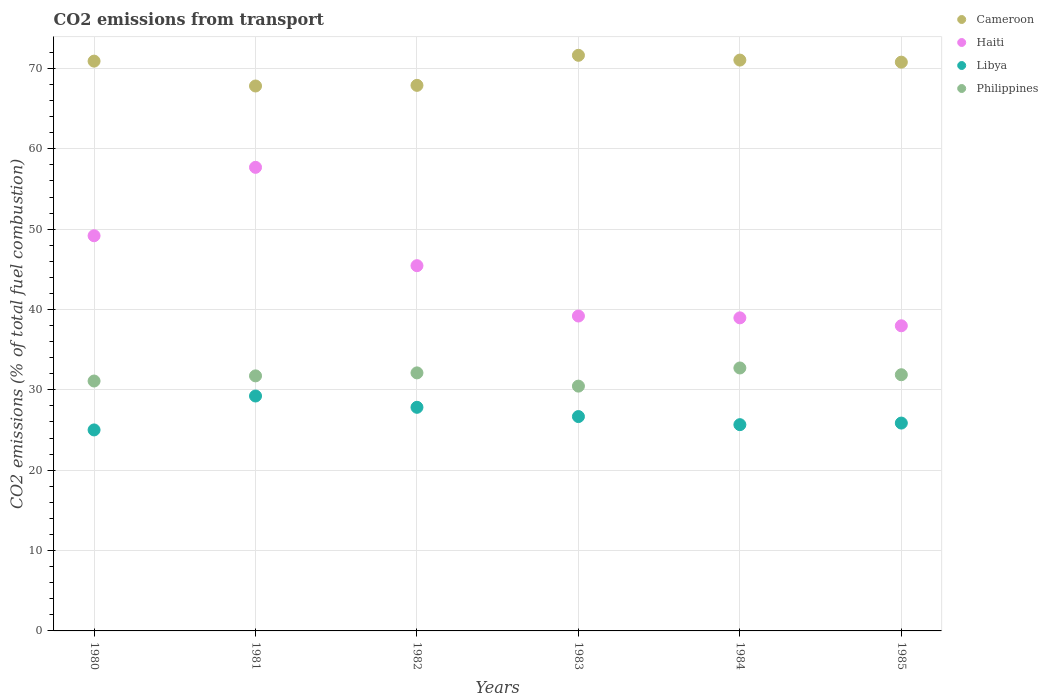What is the total CO2 emitted in Haiti in 1980?
Make the answer very short. 49.18. Across all years, what is the maximum total CO2 emitted in Philippines?
Ensure brevity in your answer.  32.72. Across all years, what is the minimum total CO2 emitted in Philippines?
Make the answer very short. 30.46. In which year was the total CO2 emitted in Cameroon minimum?
Your answer should be very brief. 1981. What is the total total CO2 emitted in Philippines in the graph?
Your answer should be compact. 190.02. What is the difference between the total CO2 emitted in Cameroon in 1981 and that in 1984?
Offer a terse response. -3.22. What is the difference between the total CO2 emitted in Haiti in 1985 and the total CO2 emitted in Cameroon in 1984?
Make the answer very short. -33.07. What is the average total CO2 emitted in Cameroon per year?
Offer a very short reply. 70.01. In the year 1983, what is the difference between the total CO2 emitted in Libya and total CO2 emitted in Haiti?
Offer a very short reply. -12.51. In how many years, is the total CO2 emitted in Libya greater than 58?
Offer a terse response. 0. What is the ratio of the total CO2 emitted in Philippines in 1980 to that in 1983?
Provide a succinct answer. 1.02. Is the total CO2 emitted in Cameroon in 1982 less than that in 1984?
Ensure brevity in your answer.  Yes. What is the difference between the highest and the second highest total CO2 emitted in Libya?
Your answer should be compact. 1.41. What is the difference between the highest and the lowest total CO2 emitted in Haiti?
Make the answer very short. 19.72. Is it the case that in every year, the sum of the total CO2 emitted in Haiti and total CO2 emitted in Philippines  is greater than the sum of total CO2 emitted in Cameroon and total CO2 emitted in Libya?
Provide a short and direct response. No. How many dotlines are there?
Your answer should be compact. 4. How many years are there in the graph?
Give a very brief answer. 6. What is the difference between two consecutive major ticks on the Y-axis?
Give a very brief answer. 10. Are the values on the major ticks of Y-axis written in scientific E-notation?
Your response must be concise. No. Does the graph contain grids?
Ensure brevity in your answer.  Yes. Where does the legend appear in the graph?
Give a very brief answer. Top right. What is the title of the graph?
Ensure brevity in your answer.  CO2 emissions from transport. What is the label or title of the X-axis?
Your response must be concise. Years. What is the label or title of the Y-axis?
Offer a terse response. CO2 emissions (% of total fuel combustion). What is the CO2 emissions (% of total fuel combustion) of Cameroon in 1980?
Provide a succinct answer. 70.91. What is the CO2 emissions (% of total fuel combustion) of Haiti in 1980?
Keep it short and to the point. 49.18. What is the CO2 emissions (% of total fuel combustion) in Libya in 1980?
Your answer should be compact. 25.01. What is the CO2 emissions (% of total fuel combustion) in Philippines in 1980?
Make the answer very short. 31.1. What is the CO2 emissions (% of total fuel combustion) of Cameroon in 1981?
Offer a terse response. 67.82. What is the CO2 emissions (% of total fuel combustion) of Haiti in 1981?
Offer a terse response. 57.69. What is the CO2 emissions (% of total fuel combustion) of Libya in 1981?
Your answer should be very brief. 29.23. What is the CO2 emissions (% of total fuel combustion) of Philippines in 1981?
Give a very brief answer. 31.74. What is the CO2 emissions (% of total fuel combustion) of Cameroon in 1982?
Provide a succinct answer. 67.89. What is the CO2 emissions (% of total fuel combustion) in Haiti in 1982?
Ensure brevity in your answer.  45.45. What is the CO2 emissions (% of total fuel combustion) in Libya in 1982?
Offer a very short reply. 27.83. What is the CO2 emissions (% of total fuel combustion) of Philippines in 1982?
Ensure brevity in your answer.  32.11. What is the CO2 emissions (% of total fuel combustion) of Cameroon in 1983?
Make the answer very short. 71.63. What is the CO2 emissions (% of total fuel combustion) of Haiti in 1983?
Provide a short and direct response. 39.19. What is the CO2 emissions (% of total fuel combustion) in Libya in 1983?
Provide a succinct answer. 26.68. What is the CO2 emissions (% of total fuel combustion) in Philippines in 1983?
Make the answer very short. 30.46. What is the CO2 emissions (% of total fuel combustion) in Cameroon in 1984?
Give a very brief answer. 71.04. What is the CO2 emissions (% of total fuel combustion) of Haiti in 1984?
Provide a succinct answer. 38.96. What is the CO2 emissions (% of total fuel combustion) of Libya in 1984?
Keep it short and to the point. 25.67. What is the CO2 emissions (% of total fuel combustion) in Philippines in 1984?
Give a very brief answer. 32.72. What is the CO2 emissions (% of total fuel combustion) in Cameroon in 1985?
Your answer should be compact. 70.78. What is the CO2 emissions (% of total fuel combustion) in Haiti in 1985?
Give a very brief answer. 37.97. What is the CO2 emissions (% of total fuel combustion) of Libya in 1985?
Ensure brevity in your answer.  25.87. What is the CO2 emissions (% of total fuel combustion) in Philippines in 1985?
Offer a very short reply. 31.88. Across all years, what is the maximum CO2 emissions (% of total fuel combustion) in Cameroon?
Provide a succinct answer. 71.63. Across all years, what is the maximum CO2 emissions (% of total fuel combustion) in Haiti?
Provide a short and direct response. 57.69. Across all years, what is the maximum CO2 emissions (% of total fuel combustion) in Libya?
Provide a succinct answer. 29.23. Across all years, what is the maximum CO2 emissions (% of total fuel combustion) in Philippines?
Provide a succinct answer. 32.72. Across all years, what is the minimum CO2 emissions (% of total fuel combustion) of Cameroon?
Offer a terse response. 67.82. Across all years, what is the minimum CO2 emissions (% of total fuel combustion) in Haiti?
Your answer should be very brief. 37.97. Across all years, what is the minimum CO2 emissions (% of total fuel combustion) of Libya?
Provide a short and direct response. 25.01. Across all years, what is the minimum CO2 emissions (% of total fuel combustion) in Philippines?
Your answer should be very brief. 30.46. What is the total CO2 emissions (% of total fuel combustion) in Cameroon in the graph?
Your answer should be compact. 420.08. What is the total CO2 emissions (% of total fuel combustion) of Haiti in the graph?
Offer a terse response. 268.45. What is the total CO2 emissions (% of total fuel combustion) in Libya in the graph?
Offer a terse response. 160.29. What is the total CO2 emissions (% of total fuel combustion) in Philippines in the graph?
Keep it short and to the point. 190.02. What is the difference between the CO2 emissions (% of total fuel combustion) of Cameroon in 1980 and that in 1981?
Your answer should be very brief. 3.09. What is the difference between the CO2 emissions (% of total fuel combustion) in Haiti in 1980 and that in 1981?
Your response must be concise. -8.51. What is the difference between the CO2 emissions (% of total fuel combustion) of Libya in 1980 and that in 1981?
Give a very brief answer. -4.22. What is the difference between the CO2 emissions (% of total fuel combustion) in Philippines in 1980 and that in 1981?
Offer a terse response. -0.64. What is the difference between the CO2 emissions (% of total fuel combustion) of Cameroon in 1980 and that in 1982?
Your response must be concise. 3.01. What is the difference between the CO2 emissions (% of total fuel combustion) of Haiti in 1980 and that in 1982?
Your answer should be compact. 3.73. What is the difference between the CO2 emissions (% of total fuel combustion) of Libya in 1980 and that in 1982?
Offer a terse response. -2.82. What is the difference between the CO2 emissions (% of total fuel combustion) of Philippines in 1980 and that in 1982?
Ensure brevity in your answer.  -1.01. What is the difference between the CO2 emissions (% of total fuel combustion) in Cameroon in 1980 and that in 1983?
Give a very brief answer. -0.73. What is the difference between the CO2 emissions (% of total fuel combustion) in Haiti in 1980 and that in 1983?
Make the answer very short. 9.99. What is the difference between the CO2 emissions (% of total fuel combustion) of Libya in 1980 and that in 1983?
Keep it short and to the point. -1.66. What is the difference between the CO2 emissions (% of total fuel combustion) of Philippines in 1980 and that in 1983?
Make the answer very short. 0.64. What is the difference between the CO2 emissions (% of total fuel combustion) of Cameroon in 1980 and that in 1984?
Your response must be concise. -0.13. What is the difference between the CO2 emissions (% of total fuel combustion) in Haiti in 1980 and that in 1984?
Ensure brevity in your answer.  10.22. What is the difference between the CO2 emissions (% of total fuel combustion) in Libya in 1980 and that in 1984?
Your response must be concise. -0.66. What is the difference between the CO2 emissions (% of total fuel combustion) of Philippines in 1980 and that in 1984?
Keep it short and to the point. -1.62. What is the difference between the CO2 emissions (% of total fuel combustion) of Cameroon in 1980 and that in 1985?
Ensure brevity in your answer.  0.13. What is the difference between the CO2 emissions (% of total fuel combustion) of Haiti in 1980 and that in 1985?
Make the answer very short. 11.21. What is the difference between the CO2 emissions (% of total fuel combustion) of Libya in 1980 and that in 1985?
Offer a very short reply. -0.85. What is the difference between the CO2 emissions (% of total fuel combustion) in Philippines in 1980 and that in 1985?
Ensure brevity in your answer.  -0.78. What is the difference between the CO2 emissions (% of total fuel combustion) in Cameroon in 1981 and that in 1982?
Your answer should be compact. -0.08. What is the difference between the CO2 emissions (% of total fuel combustion) in Haiti in 1981 and that in 1982?
Your answer should be very brief. 12.24. What is the difference between the CO2 emissions (% of total fuel combustion) of Libya in 1981 and that in 1982?
Provide a short and direct response. 1.41. What is the difference between the CO2 emissions (% of total fuel combustion) of Philippines in 1981 and that in 1982?
Provide a short and direct response. -0.37. What is the difference between the CO2 emissions (% of total fuel combustion) in Cameroon in 1981 and that in 1983?
Offer a very short reply. -3.82. What is the difference between the CO2 emissions (% of total fuel combustion) of Haiti in 1981 and that in 1983?
Offer a very short reply. 18.5. What is the difference between the CO2 emissions (% of total fuel combustion) in Libya in 1981 and that in 1983?
Offer a terse response. 2.56. What is the difference between the CO2 emissions (% of total fuel combustion) in Philippines in 1981 and that in 1983?
Your response must be concise. 1.28. What is the difference between the CO2 emissions (% of total fuel combustion) in Cameroon in 1981 and that in 1984?
Your response must be concise. -3.22. What is the difference between the CO2 emissions (% of total fuel combustion) in Haiti in 1981 and that in 1984?
Provide a succinct answer. 18.73. What is the difference between the CO2 emissions (% of total fuel combustion) in Libya in 1981 and that in 1984?
Keep it short and to the point. 3.57. What is the difference between the CO2 emissions (% of total fuel combustion) in Philippines in 1981 and that in 1984?
Provide a succinct answer. -0.98. What is the difference between the CO2 emissions (% of total fuel combustion) in Cameroon in 1981 and that in 1985?
Ensure brevity in your answer.  -2.97. What is the difference between the CO2 emissions (% of total fuel combustion) in Haiti in 1981 and that in 1985?
Offer a very short reply. 19.72. What is the difference between the CO2 emissions (% of total fuel combustion) in Libya in 1981 and that in 1985?
Give a very brief answer. 3.37. What is the difference between the CO2 emissions (% of total fuel combustion) of Philippines in 1981 and that in 1985?
Offer a very short reply. -0.14. What is the difference between the CO2 emissions (% of total fuel combustion) in Cameroon in 1982 and that in 1983?
Offer a terse response. -3.74. What is the difference between the CO2 emissions (% of total fuel combustion) in Haiti in 1982 and that in 1983?
Keep it short and to the point. 6.27. What is the difference between the CO2 emissions (% of total fuel combustion) in Libya in 1982 and that in 1983?
Your response must be concise. 1.15. What is the difference between the CO2 emissions (% of total fuel combustion) in Philippines in 1982 and that in 1983?
Ensure brevity in your answer.  1.65. What is the difference between the CO2 emissions (% of total fuel combustion) in Cameroon in 1982 and that in 1984?
Your answer should be very brief. -3.15. What is the difference between the CO2 emissions (% of total fuel combustion) in Haiti in 1982 and that in 1984?
Your answer should be compact. 6.49. What is the difference between the CO2 emissions (% of total fuel combustion) of Libya in 1982 and that in 1984?
Ensure brevity in your answer.  2.16. What is the difference between the CO2 emissions (% of total fuel combustion) in Philippines in 1982 and that in 1984?
Offer a terse response. -0.61. What is the difference between the CO2 emissions (% of total fuel combustion) of Cameroon in 1982 and that in 1985?
Ensure brevity in your answer.  -2.89. What is the difference between the CO2 emissions (% of total fuel combustion) of Haiti in 1982 and that in 1985?
Ensure brevity in your answer.  7.48. What is the difference between the CO2 emissions (% of total fuel combustion) of Libya in 1982 and that in 1985?
Ensure brevity in your answer.  1.96. What is the difference between the CO2 emissions (% of total fuel combustion) in Philippines in 1982 and that in 1985?
Ensure brevity in your answer.  0.23. What is the difference between the CO2 emissions (% of total fuel combustion) of Cameroon in 1983 and that in 1984?
Your answer should be very brief. 0.59. What is the difference between the CO2 emissions (% of total fuel combustion) of Haiti in 1983 and that in 1984?
Keep it short and to the point. 0.23. What is the difference between the CO2 emissions (% of total fuel combustion) of Libya in 1983 and that in 1984?
Your response must be concise. 1.01. What is the difference between the CO2 emissions (% of total fuel combustion) of Philippines in 1983 and that in 1984?
Make the answer very short. -2.26. What is the difference between the CO2 emissions (% of total fuel combustion) in Cameroon in 1983 and that in 1985?
Give a very brief answer. 0.85. What is the difference between the CO2 emissions (% of total fuel combustion) of Haiti in 1983 and that in 1985?
Make the answer very short. 1.21. What is the difference between the CO2 emissions (% of total fuel combustion) in Libya in 1983 and that in 1985?
Ensure brevity in your answer.  0.81. What is the difference between the CO2 emissions (% of total fuel combustion) in Philippines in 1983 and that in 1985?
Ensure brevity in your answer.  -1.42. What is the difference between the CO2 emissions (% of total fuel combustion) of Cameroon in 1984 and that in 1985?
Your response must be concise. 0.26. What is the difference between the CO2 emissions (% of total fuel combustion) in Haiti in 1984 and that in 1985?
Give a very brief answer. 0.99. What is the difference between the CO2 emissions (% of total fuel combustion) in Libya in 1984 and that in 1985?
Provide a succinct answer. -0.2. What is the difference between the CO2 emissions (% of total fuel combustion) of Philippines in 1984 and that in 1985?
Ensure brevity in your answer.  0.84. What is the difference between the CO2 emissions (% of total fuel combustion) in Cameroon in 1980 and the CO2 emissions (% of total fuel combustion) in Haiti in 1981?
Your answer should be compact. 13.22. What is the difference between the CO2 emissions (% of total fuel combustion) of Cameroon in 1980 and the CO2 emissions (% of total fuel combustion) of Libya in 1981?
Your response must be concise. 41.67. What is the difference between the CO2 emissions (% of total fuel combustion) in Cameroon in 1980 and the CO2 emissions (% of total fuel combustion) in Philippines in 1981?
Offer a very short reply. 39.17. What is the difference between the CO2 emissions (% of total fuel combustion) in Haiti in 1980 and the CO2 emissions (% of total fuel combustion) in Libya in 1981?
Your answer should be very brief. 19.95. What is the difference between the CO2 emissions (% of total fuel combustion) of Haiti in 1980 and the CO2 emissions (% of total fuel combustion) of Philippines in 1981?
Provide a short and direct response. 17.44. What is the difference between the CO2 emissions (% of total fuel combustion) of Libya in 1980 and the CO2 emissions (% of total fuel combustion) of Philippines in 1981?
Make the answer very short. -6.73. What is the difference between the CO2 emissions (% of total fuel combustion) of Cameroon in 1980 and the CO2 emissions (% of total fuel combustion) of Haiti in 1982?
Ensure brevity in your answer.  25.45. What is the difference between the CO2 emissions (% of total fuel combustion) in Cameroon in 1980 and the CO2 emissions (% of total fuel combustion) in Libya in 1982?
Your response must be concise. 43.08. What is the difference between the CO2 emissions (% of total fuel combustion) in Cameroon in 1980 and the CO2 emissions (% of total fuel combustion) in Philippines in 1982?
Your answer should be compact. 38.8. What is the difference between the CO2 emissions (% of total fuel combustion) of Haiti in 1980 and the CO2 emissions (% of total fuel combustion) of Libya in 1982?
Make the answer very short. 21.35. What is the difference between the CO2 emissions (% of total fuel combustion) in Haiti in 1980 and the CO2 emissions (% of total fuel combustion) in Philippines in 1982?
Provide a short and direct response. 17.07. What is the difference between the CO2 emissions (% of total fuel combustion) in Libya in 1980 and the CO2 emissions (% of total fuel combustion) in Philippines in 1982?
Offer a terse response. -7.1. What is the difference between the CO2 emissions (% of total fuel combustion) of Cameroon in 1980 and the CO2 emissions (% of total fuel combustion) of Haiti in 1983?
Keep it short and to the point. 31.72. What is the difference between the CO2 emissions (% of total fuel combustion) of Cameroon in 1980 and the CO2 emissions (% of total fuel combustion) of Libya in 1983?
Ensure brevity in your answer.  44.23. What is the difference between the CO2 emissions (% of total fuel combustion) in Cameroon in 1980 and the CO2 emissions (% of total fuel combustion) in Philippines in 1983?
Ensure brevity in your answer.  40.44. What is the difference between the CO2 emissions (% of total fuel combustion) of Haiti in 1980 and the CO2 emissions (% of total fuel combustion) of Libya in 1983?
Give a very brief answer. 22.5. What is the difference between the CO2 emissions (% of total fuel combustion) in Haiti in 1980 and the CO2 emissions (% of total fuel combustion) in Philippines in 1983?
Your answer should be very brief. 18.72. What is the difference between the CO2 emissions (% of total fuel combustion) in Libya in 1980 and the CO2 emissions (% of total fuel combustion) in Philippines in 1983?
Your answer should be very brief. -5.45. What is the difference between the CO2 emissions (% of total fuel combustion) of Cameroon in 1980 and the CO2 emissions (% of total fuel combustion) of Haiti in 1984?
Make the answer very short. 31.95. What is the difference between the CO2 emissions (% of total fuel combustion) in Cameroon in 1980 and the CO2 emissions (% of total fuel combustion) in Libya in 1984?
Your answer should be compact. 45.24. What is the difference between the CO2 emissions (% of total fuel combustion) in Cameroon in 1980 and the CO2 emissions (% of total fuel combustion) in Philippines in 1984?
Provide a short and direct response. 38.19. What is the difference between the CO2 emissions (% of total fuel combustion) of Haiti in 1980 and the CO2 emissions (% of total fuel combustion) of Libya in 1984?
Offer a terse response. 23.51. What is the difference between the CO2 emissions (% of total fuel combustion) in Haiti in 1980 and the CO2 emissions (% of total fuel combustion) in Philippines in 1984?
Your answer should be very brief. 16.46. What is the difference between the CO2 emissions (% of total fuel combustion) of Libya in 1980 and the CO2 emissions (% of total fuel combustion) of Philippines in 1984?
Your response must be concise. -7.71. What is the difference between the CO2 emissions (% of total fuel combustion) of Cameroon in 1980 and the CO2 emissions (% of total fuel combustion) of Haiti in 1985?
Keep it short and to the point. 32.93. What is the difference between the CO2 emissions (% of total fuel combustion) of Cameroon in 1980 and the CO2 emissions (% of total fuel combustion) of Libya in 1985?
Ensure brevity in your answer.  45.04. What is the difference between the CO2 emissions (% of total fuel combustion) of Cameroon in 1980 and the CO2 emissions (% of total fuel combustion) of Philippines in 1985?
Provide a succinct answer. 39.03. What is the difference between the CO2 emissions (% of total fuel combustion) in Haiti in 1980 and the CO2 emissions (% of total fuel combustion) in Libya in 1985?
Your answer should be very brief. 23.31. What is the difference between the CO2 emissions (% of total fuel combustion) in Haiti in 1980 and the CO2 emissions (% of total fuel combustion) in Philippines in 1985?
Give a very brief answer. 17.3. What is the difference between the CO2 emissions (% of total fuel combustion) of Libya in 1980 and the CO2 emissions (% of total fuel combustion) of Philippines in 1985?
Provide a succinct answer. -6.87. What is the difference between the CO2 emissions (% of total fuel combustion) of Cameroon in 1981 and the CO2 emissions (% of total fuel combustion) of Haiti in 1982?
Offer a very short reply. 22.36. What is the difference between the CO2 emissions (% of total fuel combustion) of Cameroon in 1981 and the CO2 emissions (% of total fuel combustion) of Libya in 1982?
Your response must be concise. 39.99. What is the difference between the CO2 emissions (% of total fuel combustion) of Cameroon in 1981 and the CO2 emissions (% of total fuel combustion) of Philippines in 1982?
Make the answer very short. 35.7. What is the difference between the CO2 emissions (% of total fuel combustion) in Haiti in 1981 and the CO2 emissions (% of total fuel combustion) in Libya in 1982?
Ensure brevity in your answer.  29.86. What is the difference between the CO2 emissions (% of total fuel combustion) in Haiti in 1981 and the CO2 emissions (% of total fuel combustion) in Philippines in 1982?
Make the answer very short. 25.58. What is the difference between the CO2 emissions (% of total fuel combustion) in Libya in 1981 and the CO2 emissions (% of total fuel combustion) in Philippines in 1982?
Offer a very short reply. -2.88. What is the difference between the CO2 emissions (% of total fuel combustion) of Cameroon in 1981 and the CO2 emissions (% of total fuel combustion) of Haiti in 1983?
Your answer should be compact. 28.63. What is the difference between the CO2 emissions (% of total fuel combustion) of Cameroon in 1981 and the CO2 emissions (% of total fuel combustion) of Libya in 1983?
Offer a very short reply. 41.14. What is the difference between the CO2 emissions (% of total fuel combustion) in Cameroon in 1981 and the CO2 emissions (% of total fuel combustion) in Philippines in 1983?
Keep it short and to the point. 37.35. What is the difference between the CO2 emissions (% of total fuel combustion) in Haiti in 1981 and the CO2 emissions (% of total fuel combustion) in Libya in 1983?
Offer a terse response. 31.02. What is the difference between the CO2 emissions (% of total fuel combustion) in Haiti in 1981 and the CO2 emissions (% of total fuel combustion) in Philippines in 1983?
Your answer should be very brief. 27.23. What is the difference between the CO2 emissions (% of total fuel combustion) of Libya in 1981 and the CO2 emissions (% of total fuel combustion) of Philippines in 1983?
Provide a succinct answer. -1.23. What is the difference between the CO2 emissions (% of total fuel combustion) in Cameroon in 1981 and the CO2 emissions (% of total fuel combustion) in Haiti in 1984?
Offer a terse response. 28.86. What is the difference between the CO2 emissions (% of total fuel combustion) of Cameroon in 1981 and the CO2 emissions (% of total fuel combustion) of Libya in 1984?
Your response must be concise. 42.15. What is the difference between the CO2 emissions (% of total fuel combustion) of Cameroon in 1981 and the CO2 emissions (% of total fuel combustion) of Philippines in 1984?
Your response must be concise. 35.09. What is the difference between the CO2 emissions (% of total fuel combustion) of Haiti in 1981 and the CO2 emissions (% of total fuel combustion) of Libya in 1984?
Keep it short and to the point. 32.02. What is the difference between the CO2 emissions (% of total fuel combustion) in Haiti in 1981 and the CO2 emissions (% of total fuel combustion) in Philippines in 1984?
Keep it short and to the point. 24.97. What is the difference between the CO2 emissions (% of total fuel combustion) in Libya in 1981 and the CO2 emissions (% of total fuel combustion) in Philippines in 1984?
Give a very brief answer. -3.49. What is the difference between the CO2 emissions (% of total fuel combustion) of Cameroon in 1981 and the CO2 emissions (% of total fuel combustion) of Haiti in 1985?
Ensure brevity in your answer.  29.84. What is the difference between the CO2 emissions (% of total fuel combustion) in Cameroon in 1981 and the CO2 emissions (% of total fuel combustion) in Libya in 1985?
Provide a succinct answer. 41.95. What is the difference between the CO2 emissions (% of total fuel combustion) in Cameroon in 1981 and the CO2 emissions (% of total fuel combustion) in Philippines in 1985?
Ensure brevity in your answer.  35.93. What is the difference between the CO2 emissions (% of total fuel combustion) in Haiti in 1981 and the CO2 emissions (% of total fuel combustion) in Libya in 1985?
Your answer should be very brief. 31.83. What is the difference between the CO2 emissions (% of total fuel combustion) in Haiti in 1981 and the CO2 emissions (% of total fuel combustion) in Philippines in 1985?
Your response must be concise. 25.81. What is the difference between the CO2 emissions (% of total fuel combustion) in Libya in 1981 and the CO2 emissions (% of total fuel combustion) in Philippines in 1985?
Your answer should be very brief. -2.65. What is the difference between the CO2 emissions (% of total fuel combustion) in Cameroon in 1982 and the CO2 emissions (% of total fuel combustion) in Haiti in 1983?
Provide a succinct answer. 28.71. What is the difference between the CO2 emissions (% of total fuel combustion) in Cameroon in 1982 and the CO2 emissions (% of total fuel combustion) in Libya in 1983?
Make the answer very short. 41.22. What is the difference between the CO2 emissions (% of total fuel combustion) in Cameroon in 1982 and the CO2 emissions (% of total fuel combustion) in Philippines in 1983?
Keep it short and to the point. 37.43. What is the difference between the CO2 emissions (% of total fuel combustion) of Haiti in 1982 and the CO2 emissions (% of total fuel combustion) of Libya in 1983?
Your answer should be compact. 18.78. What is the difference between the CO2 emissions (% of total fuel combustion) in Haiti in 1982 and the CO2 emissions (% of total fuel combustion) in Philippines in 1983?
Give a very brief answer. 14.99. What is the difference between the CO2 emissions (% of total fuel combustion) of Libya in 1982 and the CO2 emissions (% of total fuel combustion) of Philippines in 1983?
Offer a terse response. -2.64. What is the difference between the CO2 emissions (% of total fuel combustion) in Cameroon in 1982 and the CO2 emissions (% of total fuel combustion) in Haiti in 1984?
Provide a short and direct response. 28.93. What is the difference between the CO2 emissions (% of total fuel combustion) of Cameroon in 1982 and the CO2 emissions (% of total fuel combustion) of Libya in 1984?
Give a very brief answer. 42.23. What is the difference between the CO2 emissions (% of total fuel combustion) of Cameroon in 1982 and the CO2 emissions (% of total fuel combustion) of Philippines in 1984?
Make the answer very short. 35.17. What is the difference between the CO2 emissions (% of total fuel combustion) in Haiti in 1982 and the CO2 emissions (% of total fuel combustion) in Libya in 1984?
Your answer should be very brief. 19.79. What is the difference between the CO2 emissions (% of total fuel combustion) of Haiti in 1982 and the CO2 emissions (% of total fuel combustion) of Philippines in 1984?
Your response must be concise. 12.73. What is the difference between the CO2 emissions (% of total fuel combustion) of Libya in 1982 and the CO2 emissions (% of total fuel combustion) of Philippines in 1984?
Provide a succinct answer. -4.89. What is the difference between the CO2 emissions (% of total fuel combustion) of Cameroon in 1982 and the CO2 emissions (% of total fuel combustion) of Haiti in 1985?
Ensure brevity in your answer.  29.92. What is the difference between the CO2 emissions (% of total fuel combustion) of Cameroon in 1982 and the CO2 emissions (% of total fuel combustion) of Libya in 1985?
Your answer should be compact. 42.03. What is the difference between the CO2 emissions (% of total fuel combustion) of Cameroon in 1982 and the CO2 emissions (% of total fuel combustion) of Philippines in 1985?
Provide a short and direct response. 36.01. What is the difference between the CO2 emissions (% of total fuel combustion) in Haiti in 1982 and the CO2 emissions (% of total fuel combustion) in Libya in 1985?
Provide a short and direct response. 19.59. What is the difference between the CO2 emissions (% of total fuel combustion) of Haiti in 1982 and the CO2 emissions (% of total fuel combustion) of Philippines in 1985?
Give a very brief answer. 13.57. What is the difference between the CO2 emissions (% of total fuel combustion) in Libya in 1982 and the CO2 emissions (% of total fuel combustion) in Philippines in 1985?
Your answer should be very brief. -4.05. What is the difference between the CO2 emissions (% of total fuel combustion) of Cameroon in 1983 and the CO2 emissions (% of total fuel combustion) of Haiti in 1984?
Keep it short and to the point. 32.67. What is the difference between the CO2 emissions (% of total fuel combustion) in Cameroon in 1983 and the CO2 emissions (% of total fuel combustion) in Libya in 1984?
Provide a short and direct response. 45.97. What is the difference between the CO2 emissions (% of total fuel combustion) in Cameroon in 1983 and the CO2 emissions (% of total fuel combustion) in Philippines in 1984?
Your answer should be compact. 38.91. What is the difference between the CO2 emissions (% of total fuel combustion) in Haiti in 1983 and the CO2 emissions (% of total fuel combustion) in Libya in 1984?
Your answer should be very brief. 13.52. What is the difference between the CO2 emissions (% of total fuel combustion) of Haiti in 1983 and the CO2 emissions (% of total fuel combustion) of Philippines in 1984?
Provide a succinct answer. 6.47. What is the difference between the CO2 emissions (% of total fuel combustion) in Libya in 1983 and the CO2 emissions (% of total fuel combustion) in Philippines in 1984?
Give a very brief answer. -6.05. What is the difference between the CO2 emissions (% of total fuel combustion) in Cameroon in 1983 and the CO2 emissions (% of total fuel combustion) in Haiti in 1985?
Keep it short and to the point. 33.66. What is the difference between the CO2 emissions (% of total fuel combustion) in Cameroon in 1983 and the CO2 emissions (% of total fuel combustion) in Libya in 1985?
Offer a terse response. 45.77. What is the difference between the CO2 emissions (% of total fuel combustion) in Cameroon in 1983 and the CO2 emissions (% of total fuel combustion) in Philippines in 1985?
Your answer should be compact. 39.75. What is the difference between the CO2 emissions (% of total fuel combustion) in Haiti in 1983 and the CO2 emissions (% of total fuel combustion) in Libya in 1985?
Make the answer very short. 13.32. What is the difference between the CO2 emissions (% of total fuel combustion) of Haiti in 1983 and the CO2 emissions (% of total fuel combustion) of Philippines in 1985?
Keep it short and to the point. 7.31. What is the difference between the CO2 emissions (% of total fuel combustion) in Libya in 1983 and the CO2 emissions (% of total fuel combustion) in Philippines in 1985?
Keep it short and to the point. -5.21. What is the difference between the CO2 emissions (% of total fuel combustion) of Cameroon in 1984 and the CO2 emissions (% of total fuel combustion) of Haiti in 1985?
Your answer should be very brief. 33.07. What is the difference between the CO2 emissions (% of total fuel combustion) of Cameroon in 1984 and the CO2 emissions (% of total fuel combustion) of Libya in 1985?
Your answer should be very brief. 45.17. What is the difference between the CO2 emissions (% of total fuel combustion) of Cameroon in 1984 and the CO2 emissions (% of total fuel combustion) of Philippines in 1985?
Provide a short and direct response. 39.16. What is the difference between the CO2 emissions (% of total fuel combustion) of Haiti in 1984 and the CO2 emissions (% of total fuel combustion) of Libya in 1985?
Give a very brief answer. 13.09. What is the difference between the CO2 emissions (% of total fuel combustion) in Haiti in 1984 and the CO2 emissions (% of total fuel combustion) in Philippines in 1985?
Keep it short and to the point. 7.08. What is the difference between the CO2 emissions (% of total fuel combustion) in Libya in 1984 and the CO2 emissions (% of total fuel combustion) in Philippines in 1985?
Your answer should be compact. -6.21. What is the average CO2 emissions (% of total fuel combustion) of Cameroon per year?
Keep it short and to the point. 70.01. What is the average CO2 emissions (% of total fuel combustion) of Haiti per year?
Offer a very short reply. 44.74. What is the average CO2 emissions (% of total fuel combustion) of Libya per year?
Offer a terse response. 26.71. What is the average CO2 emissions (% of total fuel combustion) of Philippines per year?
Offer a terse response. 31.67. In the year 1980, what is the difference between the CO2 emissions (% of total fuel combustion) in Cameroon and CO2 emissions (% of total fuel combustion) in Haiti?
Your answer should be very brief. 21.73. In the year 1980, what is the difference between the CO2 emissions (% of total fuel combustion) of Cameroon and CO2 emissions (% of total fuel combustion) of Libya?
Your answer should be very brief. 45.9. In the year 1980, what is the difference between the CO2 emissions (% of total fuel combustion) in Cameroon and CO2 emissions (% of total fuel combustion) in Philippines?
Your response must be concise. 39.81. In the year 1980, what is the difference between the CO2 emissions (% of total fuel combustion) in Haiti and CO2 emissions (% of total fuel combustion) in Libya?
Your answer should be very brief. 24.17. In the year 1980, what is the difference between the CO2 emissions (% of total fuel combustion) in Haiti and CO2 emissions (% of total fuel combustion) in Philippines?
Your answer should be very brief. 18.08. In the year 1980, what is the difference between the CO2 emissions (% of total fuel combustion) of Libya and CO2 emissions (% of total fuel combustion) of Philippines?
Your answer should be compact. -6.09. In the year 1981, what is the difference between the CO2 emissions (% of total fuel combustion) of Cameroon and CO2 emissions (% of total fuel combustion) of Haiti?
Provide a short and direct response. 10.12. In the year 1981, what is the difference between the CO2 emissions (% of total fuel combustion) in Cameroon and CO2 emissions (% of total fuel combustion) in Libya?
Ensure brevity in your answer.  38.58. In the year 1981, what is the difference between the CO2 emissions (% of total fuel combustion) in Cameroon and CO2 emissions (% of total fuel combustion) in Philippines?
Make the answer very short. 36.08. In the year 1981, what is the difference between the CO2 emissions (% of total fuel combustion) in Haiti and CO2 emissions (% of total fuel combustion) in Libya?
Provide a succinct answer. 28.46. In the year 1981, what is the difference between the CO2 emissions (% of total fuel combustion) in Haiti and CO2 emissions (% of total fuel combustion) in Philippines?
Your answer should be very brief. 25.95. In the year 1981, what is the difference between the CO2 emissions (% of total fuel combustion) of Libya and CO2 emissions (% of total fuel combustion) of Philippines?
Make the answer very short. -2.51. In the year 1982, what is the difference between the CO2 emissions (% of total fuel combustion) of Cameroon and CO2 emissions (% of total fuel combustion) of Haiti?
Provide a succinct answer. 22.44. In the year 1982, what is the difference between the CO2 emissions (% of total fuel combustion) in Cameroon and CO2 emissions (% of total fuel combustion) in Libya?
Make the answer very short. 40.07. In the year 1982, what is the difference between the CO2 emissions (% of total fuel combustion) in Cameroon and CO2 emissions (% of total fuel combustion) in Philippines?
Your answer should be very brief. 35.78. In the year 1982, what is the difference between the CO2 emissions (% of total fuel combustion) of Haiti and CO2 emissions (% of total fuel combustion) of Libya?
Give a very brief answer. 17.63. In the year 1982, what is the difference between the CO2 emissions (% of total fuel combustion) in Haiti and CO2 emissions (% of total fuel combustion) in Philippines?
Offer a very short reply. 13.34. In the year 1982, what is the difference between the CO2 emissions (% of total fuel combustion) of Libya and CO2 emissions (% of total fuel combustion) of Philippines?
Keep it short and to the point. -4.28. In the year 1983, what is the difference between the CO2 emissions (% of total fuel combustion) of Cameroon and CO2 emissions (% of total fuel combustion) of Haiti?
Keep it short and to the point. 32.45. In the year 1983, what is the difference between the CO2 emissions (% of total fuel combustion) in Cameroon and CO2 emissions (% of total fuel combustion) in Libya?
Your answer should be very brief. 44.96. In the year 1983, what is the difference between the CO2 emissions (% of total fuel combustion) of Cameroon and CO2 emissions (% of total fuel combustion) of Philippines?
Your answer should be very brief. 41.17. In the year 1983, what is the difference between the CO2 emissions (% of total fuel combustion) of Haiti and CO2 emissions (% of total fuel combustion) of Libya?
Your answer should be compact. 12.51. In the year 1983, what is the difference between the CO2 emissions (% of total fuel combustion) of Haiti and CO2 emissions (% of total fuel combustion) of Philippines?
Your answer should be very brief. 8.72. In the year 1983, what is the difference between the CO2 emissions (% of total fuel combustion) in Libya and CO2 emissions (% of total fuel combustion) in Philippines?
Offer a very short reply. -3.79. In the year 1984, what is the difference between the CO2 emissions (% of total fuel combustion) of Cameroon and CO2 emissions (% of total fuel combustion) of Haiti?
Provide a succinct answer. 32.08. In the year 1984, what is the difference between the CO2 emissions (% of total fuel combustion) in Cameroon and CO2 emissions (% of total fuel combustion) in Libya?
Provide a short and direct response. 45.37. In the year 1984, what is the difference between the CO2 emissions (% of total fuel combustion) in Cameroon and CO2 emissions (% of total fuel combustion) in Philippines?
Provide a short and direct response. 38.32. In the year 1984, what is the difference between the CO2 emissions (% of total fuel combustion) of Haiti and CO2 emissions (% of total fuel combustion) of Libya?
Provide a short and direct response. 13.29. In the year 1984, what is the difference between the CO2 emissions (% of total fuel combustion) of Haiti and CO2 emissions (% of total fuel combustion) of Philippines?
Offer a terse response. 6.24. In the year 1984, what is the difference between the CO2 emissions (% of total fuel combustion) in Libya and CO2 emissions (% of total fuel combustion) in Philippines?
Your response must be concise. -7.05. In the year 1985, what is the difference between the CO2 emissions (% of total fuel combustion) in Cameroon and CO2 emissions (% of total fuel combustion) in Haiti?
Offer a very short reply. 32.81. In the year 1985, what is the difference between the CO2 emissions (% of total fuel combustion) in Cameroon and CO2 emissions (% of total fuel combustion) in Libya?
Offer a terse response. 44.92. In the year 1985, what is the difference between the CO2 emissions (% of total fuel combustion) of Cameroon and CO2 emissions (% of total fuel combustion) of Philippines?
Offer a terse response. 38.9. In the year 1985, what is the difference between the CO2 emissions (% of total fuel combustion) of Haiti and CO2 emissions (% of total fuel combustion) of Libya?
Provide a short and direct response. 12.11. In the year 1985, what is the difference between the CO2 emissions (% of total fuel combustion) in Haiti and CO2 emissions (% of total fuel combustion) in Philippines?
Your response must be concise. 6.09. In the year 1985, what is the difference between the CO2 emissions (% of total fuel combustion) in Libya and CO2 emissions (% of total fuel combustion) in Philippines?
Offer a terse response. -6.02. What is the ratio of the CO2 emissions (% of total fuel combustion) in Cameroon in 1980 to that in 1981?
Your answer should be compact. 1.05. What is the ratio of the CO2 emissions (% of total fuel combustion) in Haiti in 1980 to that in 1981?
Provide a succinct answer. 0.85. What is the ratio of the CO2 emissions (% of total fuel combustion) of Libya in 1980 to that in 1981?
Provide a short and direct response. 0.86. What is the ratio of the CO2 emissions (% of total fuel combustion) in Philippines in 1980 to that in 1981?
Keep it short and to the point. 0.98. What is the ratio of the CO2 emissions (% of total fuel combustion) in Cameroon in 1980 to that in 1982?
Keep it short and to the point. 1.04. What is the ratio of the CO2 emissions (% of total fuel combustion) in Haiti in 1980 to that in 1982?
Provide a succinct answer. 1.08. What is the ratio of the CO2 emissions (% of total fuel combustion) of Libya in 1980 to that in 1982?
Your answer should be very brief. 0.9. What is the ratio of the CO2 emissions (% of total fuel combustion) in Philippines in 1980 to that in 1982?
Offer a very short reply. 0.97. What is the ratio of the CO2 emissions (% of total fuel combustion) of Haiti in 1980 to that in 1983?
Make the answer very short. 1.25. What is the ratio of the CO2 emissions (% of total fuel combustion) in Libya in 1980 to that in 1983?
Keep it short and to the point. 0.94. What is the ratio of the CO2 emissions (% of total fuel combustion) in Philippines in 1980 to that in 1983?
Your response must be concise. 1.02. What is the ratio of the CO2 emissions (% of total fuel combustion) in Cameroon in 1980 to that in 1984?
Your answer should be compact. 1. What is the ratio of the CO2 emissions (% of total fuel combustion) of Haiti in 1980 to that in 1984?
Give a very brief answer. 1.26. What is the ratio of the CO2 emissions (% of total fuel combustion) of Libya in 1980 to that in 1984?
Make the answer very short. 0.97. What is the ratio of the CO2 emissions (% of total fuel combustion) in Philippines in 1980 to that in 1984?
Your answer should be compact. 0.95. What is the ratio of the CO2 emissions (% of total fuel combustion) in Haiti in 1980 to that in 1985?
Offer a terse response. 1.3. What is the ratio of the CO2 emissions (% of total fuel combustion) of Libya in 1980 to that in 1985?
Provide a succinct answer. 0.97. What is the ratio of the CO2 emissions (% of total fuel combustion) of Philippines in 1980 to that in 1985?
Your answer should be compact. 0.98. What is the ratio of the CO2 emissions (% of total fuel combustion) of Haiti in 1981 to that in 1982?
Provide a succinct answer. 1.27. What is the ratio of the CO2 emissions (% of total fuel combustion) of Libya in 1981 to that in 1982?
Offer a very short reply. 1.05. What is the ratio of the CO2 emissions (% of total fuel combustion) of Philippines in 1981 to that in 1982?
Provide a short and direct response. 0.99. What is the ratio of the CO2 emissions (% of total fuel combustion) in Cameroon in 1981 to that in 1983?
Your answer should be compact. 0.95. What is the ratio of the CO2 emissions (% of total fuel combustion) of Haiti in 1981 to that in 1983?
Your answer should be compact. 1.47. What is the ratio of the CO2 emissions (% of total fuel combustion) of Libya in 1981 to that in 1983?
Give a very brief answer. 1.1. What is the ratio of the CO2 emissions (% of total fuel combustion) in Philippines in 1981 to that in 1983?
Provide a succinct answer. 1.04. What is the ratio of the CO2 emissions (% of total fuel combustion) in Cameroon in 1981 to that in 1984?
Offer a terse response. 0.95. What is the ratio of the CO2 emissions (% of total fuel combustion) of Haiti in 1981 to that in 1984?
Ensure brevity in your answer.  1.48. What is the ratio of the CO2 emissions (% of total fuel combustion) in Libya in 1981 to that in 1984?
Offer a terse response. 1.14. What is the ratio of the CO2 emissions (% of total fuel combustion) in Cameroon in 1981 to that in 1985?
Offer a very short reply. 0.96. What is the ratio of the CO2 emissions (% of total fuel combustion) in Haiti in 1981 to that in 1985?
Offer a very short reply. 1.52. What is the ratio of the CO2 emissions (% of total fuel combustion) in Libya in 1981 to that in 1985?
Provide a short and direct response. 1.13. What is the ratio of the CO2 emissions (% of total fuel combustion) of Cameroon in 1982 to that in 1983?
Provide a short and direct response. 0.95. What is the ratio of the CO2 emissions (% of total fuel combustion) in Haiti in 1982 to that in 1983?
Your answer should be compact. 1.16. What is the ratio of the CO2 emissions (% of total fuel combustion) of Libya in 1982 to that in 1983?
Provide a succinct answer. 1.04. What is the ratio of the CO2 emissions (% of total fuel combustion) of Philippines in 1982 to that in 1983?
Ensure brevity in your answer.  1.05. What is the ratio of the CO2 emissions (% of total fuel combustion) of Cameroon in 1982 to that in 1984?
Provide a succinct answer. 0.96. What is the ratio of the CO2 emissions (% of total fuel combustion) in Libya in 1982 to that in 1984?
Give a very brief answer. 1.08. What is the ratio of the CO2 emissions (% of total fuel combustion) of Philippines in 1982 to that in 1984?
Make the answer very short. 0.98. What is the ratio of the CO2 emissions (% of total fuel combustion) of Cameroon in 1982 to that in 1985?
Keep it short and to the point. 0.96. What is the ratio of the CO2 emissions (% of total fuel combustion) of Haiti in 1982 to that in 1985?
Your response must be concise. 1.2. What is the ratio of the CO2 emissions (% of total fuel combustion) in Libya in 1982 to that in 1985?
Give a very brief answer. 1.08. What is the ratio of the CO2 emissions (% of total fuel combustion) in Cameroon in 1983 to that in 1984?
Make the answer very short. 1.01. What is the ratio of the CO2 emissions (% of total fuel combustion) in Haiti in 1983 to that in 1984?
Your answer should be very brief. 1.01. What is the ratio of the CO2 emissions (% of total fuel combustion) in Libya in 1983 to that in 1984?
Your answer should be compact. 1.04. What is the ratio of the CO2 emissions (% of total fuel combustion) in Cameroon in 1983 to that in 1985?
Your answer should be very brief. 1.01. What is the ratio of the CO2 emissions (% of total fuel combustion) in Haiti in 1983 to that in 1985?
Provide a succinct answer. 1.03. What is the ratio of the CO2 emissions (% of total fuel combustion) in Libya in 1983 to that in 1985?
Offer a terse response. 1.03. What is the ratio of the CO2 emissions (% of total fuel combustion) of Philippines in 1983 to that in 1985?
Offer a very short reply. 0.96. What is the ratio of the CO2 emissions (% of total fuel combustion) of Libya in 1984 to that in 1985?
Provide a short and direct response. 0.99. What is the ratio of the CO2 emissions (% of total fuel combustion) in Philippines in 1984 to that in 1985?
Give a very brief answer. 1.03. What is the difference between the highest and the second highest CO2 emissions (% of total fuel combustion) of Cameroon?
Give a very brief answer. 0.59. What is the difference between the highest and the second highest CO2 emissions (% of total fuel combustion) in Haiti?
Provide a short and direct response. 8.51. What is the difference between the highest and the second highest CO2 emissions (% of total fuel combustion) in Libya?
Offer a very short reply. 1.41. What is the difference between the highest and the second highest CO2 emissions (% of total fuel combustion) in Philippines?
Your answer should be very brief. 0.61. What is the difference between the highest and the lowest CO2 emissions (% of total fuel combustion) of Cameroon?
Ensure brevity in your answer.  3.82. What is the difference between the highest and the lowest CO2 emissions (% of total fuel combustion) of Haiti?
Provide a short and direct response. 19.72. What is the difference between the highest and the lowest CO2 emissions (% of total fuel combustion) of Libya?
Your answer should be compact. 4.22. What is the difference between the highest and the lowest CO2 emissions (% of total fuel combustion) of Philippines?
Give a very brief answer. 2.26. 